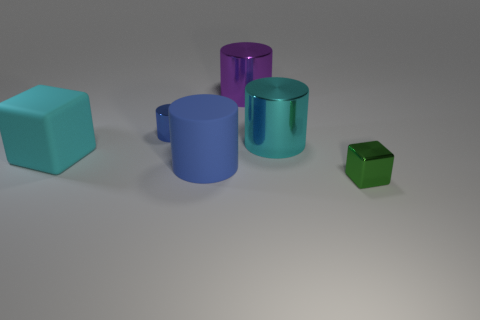What number of blue objects are made of the same material as the big block?
Offer a terse response. 1. Is the number of big cyan cylinders less than the number of small shiny objects?
Ensure brevity in your answer.  Yes. There is a tiny object on the left side of the tiny block; is it the same color as the small metallic cube?
Offer a very short reply. No. What number of large blue objects are to the left of the block on the right side of the large cyan object on the right side of the matte cylinder?
Ensure brevity in your answer.  1. How many tiny blue cylinders are behind the green cube?
Offer a terse response. 1. What color is the rubber thing that is the same shape as the blue shiny thing?
Your response must be concise. Blue. What material is the thing that is behind the big blue cylinder and to the right of the large purple metal cylinder?
Provide a succinct answer. Metal. Do the metal cylinder that is behind the blue shiny thing and the blue metallic object have the same size?
Offer a very short reply. No. What is the tiny blue cylinder made of?
Offer a terse response. Metal. There is a shiny object behind the tiny cylinder; what is its color?
Offer a very short reply. Purple. 